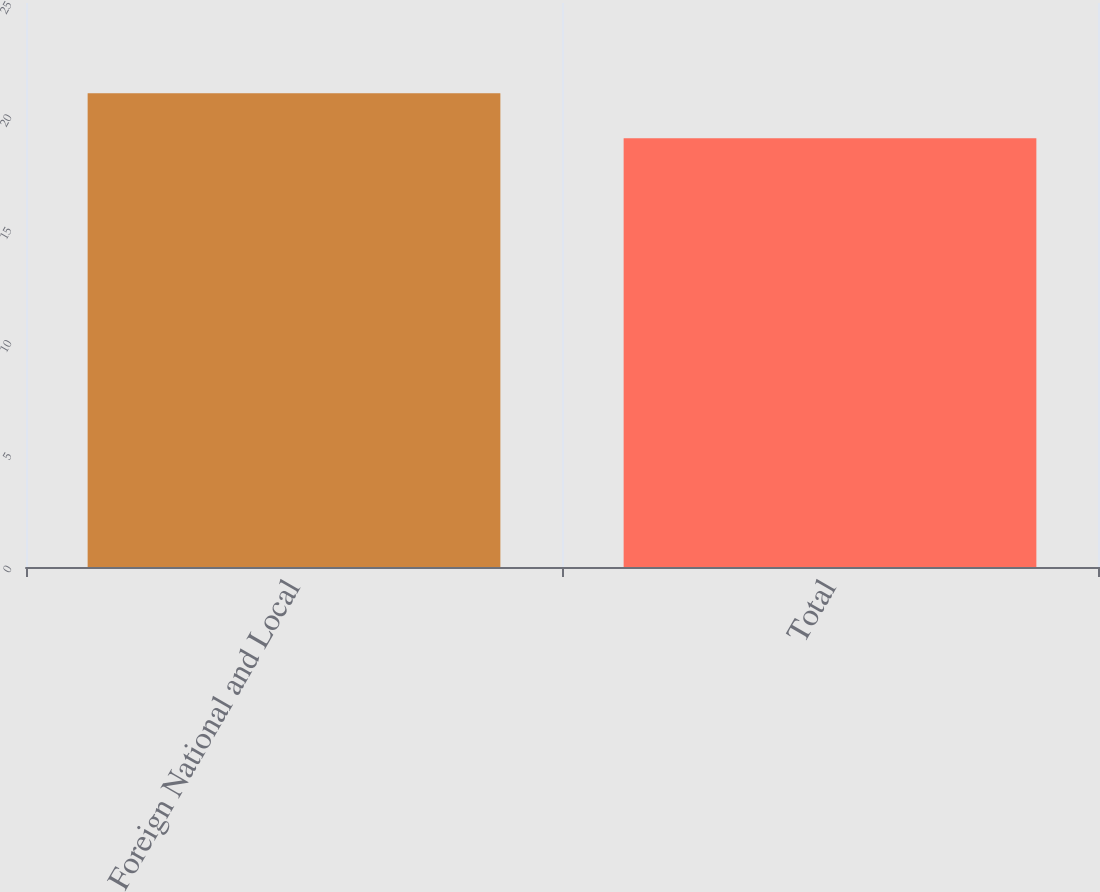Convert chart to OTSL. <chart><loc_0><loc_0><loc_500><loc_500><bar_chart><fcel>Foreign National and Local<fcel>Total<nl><fcel>21<fcel>19<nl></chart> 